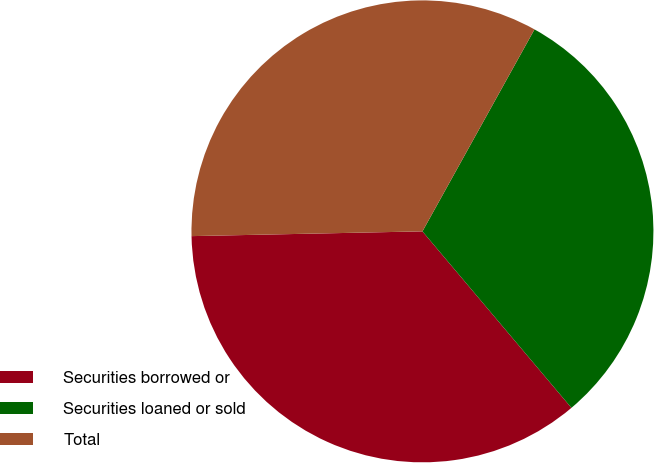<chart> <loc_0><loc_0><loc_500><loc_500><pie_chart><fcel>Securities borrowed or<fcel>Securities loaned or sold<fcel>Total<nl><fcel>35.83%<fcel>30.78%<fcel>33.39%<nl></chart> 